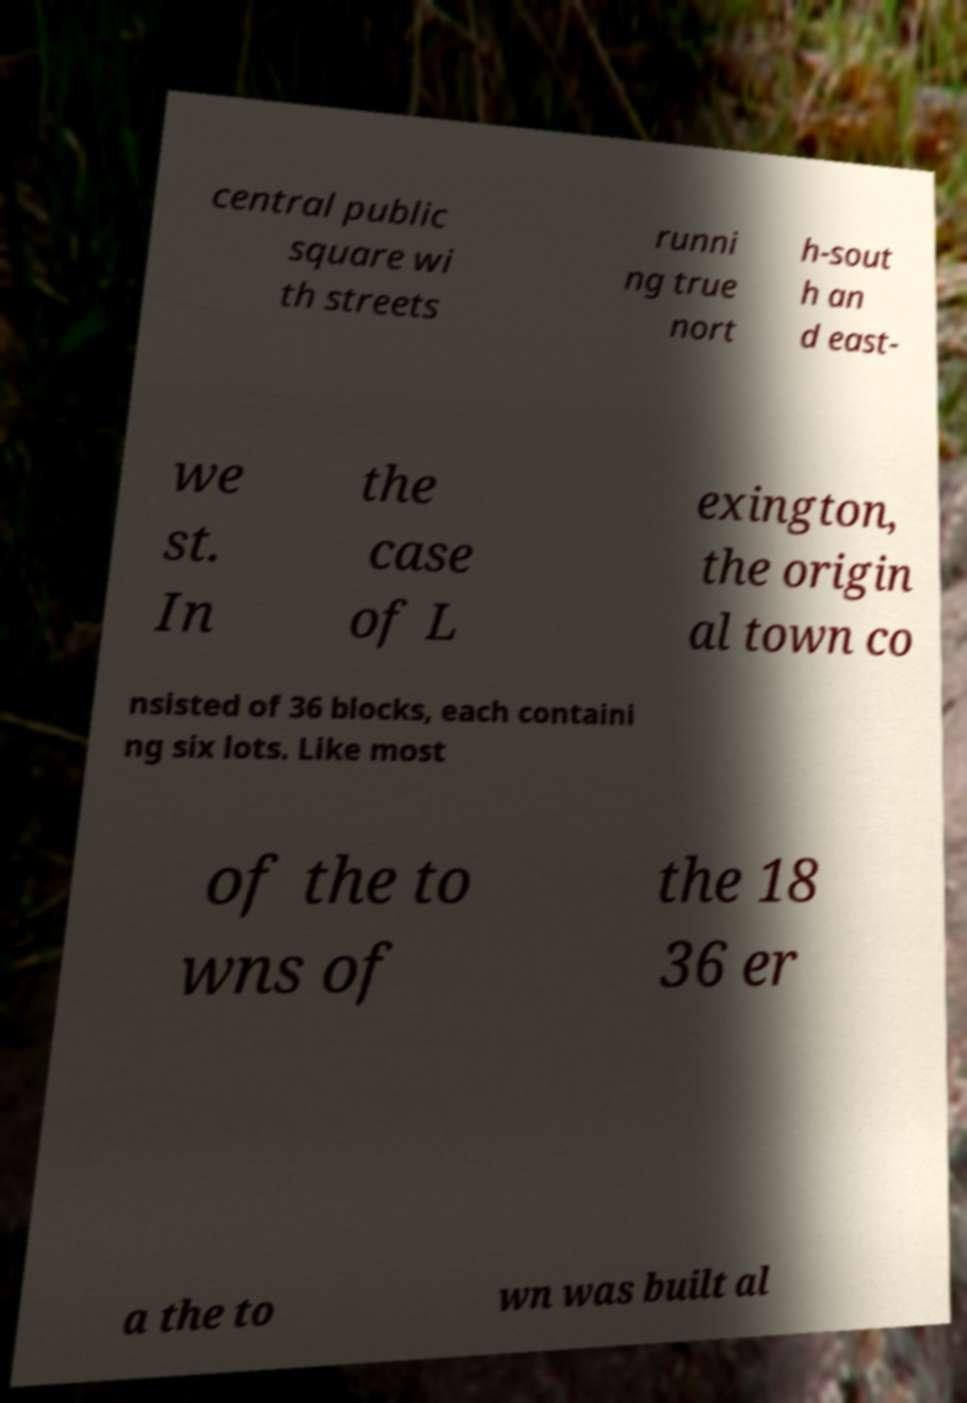For documentation purposes, I need the text within this image transcribed. Could you provide that? central public square wi th streets runni ng true nort h-sout h an d east- we st. In the case of L exington, the origin al town co nsisted of 36 blocks, each containi ng six lots. Like most of the to wns of the 18 36 er a the to wn was built al 